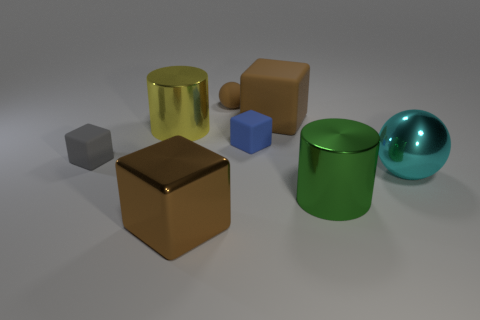Subtract 1 cubes. How many cubes are left? 3 Add 1 brown things. How many objects exist? 9 Subtract all spheres. How many objects are left? 6 Subtract 0 brown cylinders. How many objects are left? 8 Subtract all big red objects. Subtract all green metal cylinders. How many objects are left? 7 Add 4 big cylinders. How many big cylinders are left? 6 Add 2 red matte blocks. How many red matte blocks exist? 2 